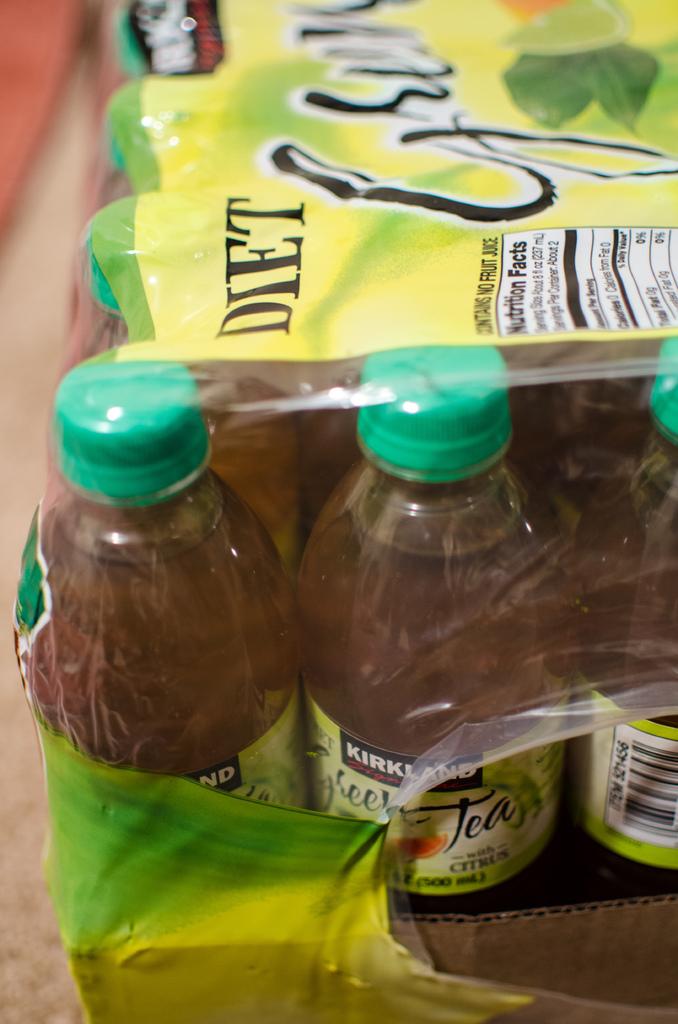What kind of beverage is this?
Keep it short and to the point. Tea. 